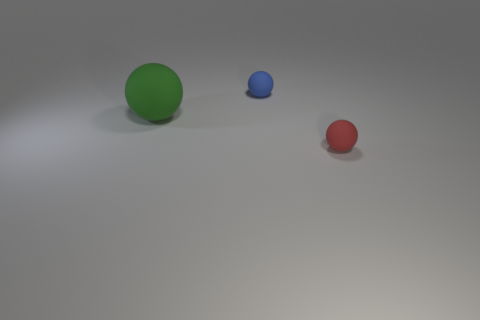Are there any other things that have the same size as the green object?
Ensure brevity in your answer.  No. There is a rubber object that is left of the small object to the left of the rubber ball that is in front of the large green ball; what is its size?
Ensure brevity in your answer.  Large. What color is the rubber object that is to the left of the blue sphere?
Provide a short and direct response. Green. Are there more tiny matte balls to the left of the green matte ball than green rubber balls?
Provide a succinct answer. No. Does the matte object that is left of the small blue ball have the same shape as the red rubber thing?
Provide a succinct answer. Yes. How many cyan objects are tiny things or big rubber objects?
Your answer should be compact. 0. Is the number of small balls greater than the number of metallic balls?
Keep it short and to the point. Yes. The other ball that is the same size as the blue matte sphere is what color?
Your answer should be very brief. Red. What number of blocks are either big matte objects or red objects?
Make the answer very short. 0. Is the shape of the green object the same as the object in front of the large green ball?
Ensure brevity in your answer.  Yes. 